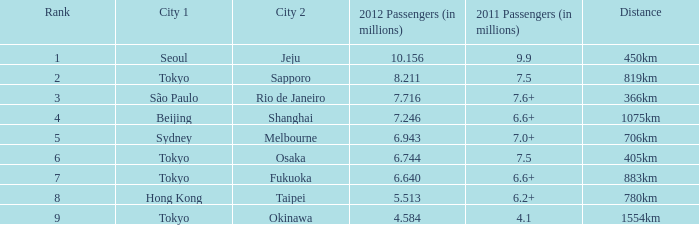Could you parse the entire table? {'header': ['Rank', 'City 1', 'City 2', '2012 Passengers (in millions)', '2011 Passengers (in millions)', 'Distance'], 'rows': [['1', 'Seoul', 'Jeju', '10.156', '9.9', '450km'], ['2', 'Tokyo', 'Sapporo', '8.211', '7.5', '819km'], ['3', 'São Paulo', 'Rio de Janeiro', '7.716', '7.6+', '366km'], ['4', 'Beijing', 'Shanghai', '7.246', '6.6+', '1075km'], ['5', 'Sydney', 'Melbourne', '6.943', '7.0+', '706km'], ['6', 'Tokyo', 'Osaka', '6.744', '7.5', '405km'], ['7', 'Tokyo', 'Fukuoka', '6.640', '6.6+', '883km'], ['8', 'Hong Kong', 'Taipei', '5.513', '6.2+', '780km'], ['9', 'Tokyo', 'Okinawa', '4.584', '4.1', '1554km']]} How many passengers (in millions) in 2011 flew through along the route that had 6.640 million passengers in 2012? 6.6+. 